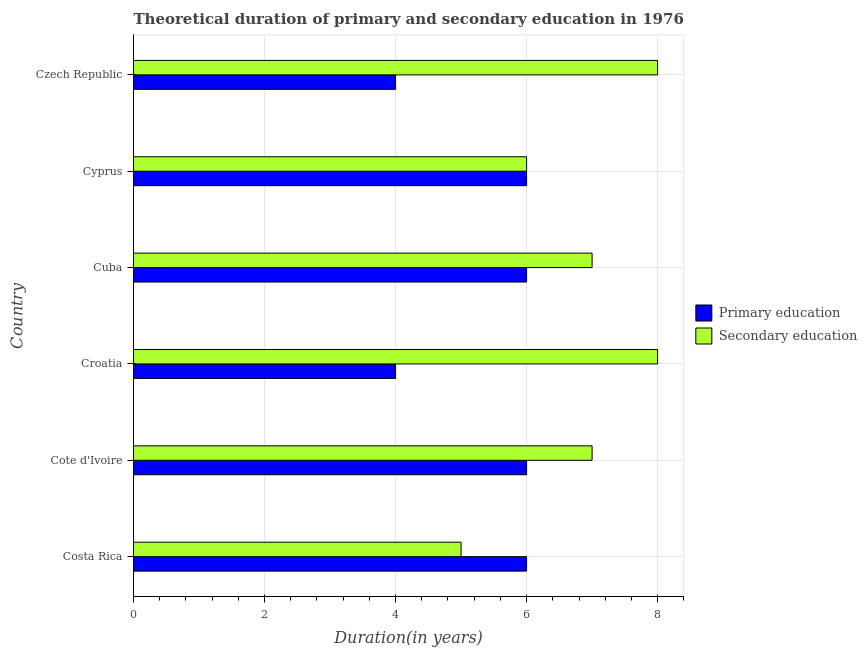How many groups of bars are there?
Your answer should be very brief. 6. Are the number of bars per tick equal to the number of legend labels?
Provide a succinct answer. Yes. Are the number of bars on each tick of the Y-axis equal?
Give a very brief answer. Yes. What is the label of the 2nd group of bars from the top?
Offer a very short reply. Cyprus. In how many cases, is the number of bars for a given country not equal to the number of legend labels?
Ensure brevity in your answer.  0. What is the duration of primary education in Cote d'Ivoire?
Provide a succinct answer. 6. Across all countries, what is the maximum duration of secondary education?
Your response must be concise. 8. Across all countries, what is the minimum duration of primary education?
Make the answer very short. 4. In which country was the duration of secondary education maximum?
Offer a terse response. Croatia. What is the total duration of secondary education in the graph?
Provide a succinct answer. 41. What is the difference between the duration of primary education in Cuba and that in Czech Republic?
Make the answer very short. 2. What is the difference between the duration of secondary education in Croatia and the duration of primary education in Cote d'Ivoire?
Make the answer very short. 2. What is the average duration of primary education per country?
Ensure brevity in your answer.  5.33. What is the difference between the duration of primary education and duration of secondary education in Costa Rica?
Your answer should be compact. 1. In how many countries, is the duration of secondary education greater than 1.2000000000000002 years?
Give a very brief answer. 6. What is the ratio of the duration of secondary education in Cote d'Ivoire to that in Cyprus?
Your answer should be very brief. 1.17. What is the difference between the highest and the second highest duration of primary education?
Your answer should be compact. 0. What is the difference between the highest and the lowest duration of secondary education?
Keep it short and to the point. 3. Is the sum of the duration of secondary education in Costa Rica and Cyprus greater than the maximum duration of primary education across all countries?
Make the answer very short. Yes. What does the 1st bar from the top in Costa Rica represents?
Make the answer very short. Secondary education. How many bars are there?
Provide a succinct answer. 12. Are all the bars in the graph horizontal?
Offer a very short reply. Yes. Does the graph contain grids?
Give a very brief answer. Yes. Where does the legend appear in the graph?
Your answer should be very brief. Center right. How many legend labels are there?
Your answer should be very brief. 2. What is the title of the graph?
Keep it short and to the point. Theoretical duration of primary and secondary education in 1976. Does "Measles" appear as one of the legend labels in the graph?
Your response must be concise. No. What is the label or title of the X-axis?
Keep it short and to the point. Duration(in years). What is the label or title of the Y-axis?
Give a very brief answer. Country. What is the Duration(in years) of Secondary education in Costa Rica?
Offer a very short reply. 5. What is the Duration(in years) in Primary education in Croatia?
Provide a short and direct response. 4. What is the Duration(in years) of Secondary education in Cuba?
Make the answer very short. 7. What is the Duration(in years) in Primary education in Czech Republic?
Provide a succinct answer. 4. What is the Duration(in years) in Secondary education in Czech Republic?
Give a very brief answer. 8. Across all countries, what is the maximum Duration(in years) in Primary education?
Offer a terse response. 6. Across all countries, what is the maximum Duration(in years) of Secondary education?
Offer a terse response. 8. What is the total Duration(in years) of Secondary education in the graph?
Ensure brevity in your answer.  41. What is the difference between the Duration(in years) in Primary education in Costa Rica and that in Cote d'Ivoire?
Keep it short and to the point. 0. What is the difference between the Duration(in years) of Secondary education in Costa Rica and that in Cote d'Ivoire?
Give a very brief answer. -2. What is the difference between the Duration(in years) in Primary education in Costa Rica and that in Croatia?
Ensure brevity in your answer.  2. What is the difference between the Duration(in years) of Primary education in Costa Rica and that in Czech Republic?
Make the answer very short. 2. What is the difference between the Duration(in years) of Secondary education in Costa Rica and that in Czech Republic?
Offer a terse response. -3. What is the difference between the Duration(in years) in Secondary education in Cote d'Ivoire and that in Croatia?
Give a very brief answer. -1. What is the difference between the Duration(in years) in Primary education in Cote d'Ivoire and that in Cuba?
Ensure brevity in your answer.  0. What is the difference between the Duration(in years) in Secondary education in Cote d'Ivoire and that in Cuba?
Offer a very short reply. 0. What is the difference between the Duration(in years) in Secondary education in Cote d'Ivoire and that in Czech Republic?
Your response must be concise. -1. What is the difference between the Duration(in years) of Primary education in Croatia and that in Cuba?
Your answer should be compact. -2. What is the difference between the Duration(in years) in Secondary education in Croatia and that in Cyprus?
Your answer should be very brief. 2. What is the difference between the Duration(in years) of Primary education in Cuba and that in Czech Republic?
Provide a short and direct response. 2. What is the difference between the Duration(in years) of Secondary education in Cuba and that in Czech Republic?
Your response must be concise. -1. What is the difference between the Duration(in years) of Secondary education in Cyprus and that in Czech Republic?
Ensure brevity in your answer.  -2. What is the difference between the Duration(in years) of Primary education in Costa Rica and the Duration(in years) of Secondary education in Cote d'Ivoire?
Your answer should be compact. -1. What is the difference between the Duration(in years) of Primary education in Costa Rica and the Duration(in years) of Secondary education in Cuba?
Give a very brief answer. -1. What is the difference between the Duration(in years) in Primary education in Costa Rica and the Duration(in years) in Secondary education in Czech Republic?
Your response must be concise. -2. What is the difference between the Duration(in years) in Primary education in Cote d'Ivoire and the Duration(in years) in Secondary education in Croatia?
Provide a succinct answer. -2. What is the difference between the Duration(in years) in Primary education in Cote d'Ivoire and the Duration(in years) in Secondary education in Cuba?
Offer a very short reply. -1. What is the difference between the Duration(in years) in Primary education in Cote d'Ivoire and the Duration(in years) in Secondary education in Czech Republic?
Give a very brief answer. -2. What is the difference between the Duration(in years) in Primary education in Croatia and the Duration(in years) in Secondary education in Cuba?
Provide a short and direct response. -3. What is the difference between the Duration(in years) of Primary education in Croatia and the Duration(in years) of Secondary education in Czech Republic?
Your response must be concise. -4. What is the average Duration(in years) in Primary education per country?
Your response must be concise. 5.33. What is the average Duration(in years) in Secondary education per country?
Your answer should be very brief. 6.83. What is the difference between the Duration(in years) in Primary education and Duration(in years) in Secondary education in Costa Rica?
Your answer should be compact. 1. What is the ratio of the Duration(in years) in Secondary education in Costa Rica to that in Cote d'Ivoire?
Offer a very short reply. 0.71. What is the ratio of the Duration(in years) of Primary education in Costa Rica to that in Cuba?
Offer a very short reply. 1. What is the ratio of the Duration(in years) in Primary education in Costa Rica to that in Cyprus?
Offer a terse response. 1. What is the ratio of the Duration(in years) in Secondary education in Costa Rica to that in Cyprus?
Keep it short and to the point. 0.83. What is the ratio of the Duration(in years) in Secondary education in Costa Rica to that in Czech Republic?
Keep it short and to the point. 0.62. What is the ratio of the Duration(in years) in Primary education in Cote d'Ivoire to that in Croatia?
Your answer should be very brief. 1.5. What is the ratio of the Duration(in years) of Primary education in Cote d'Ivoire to that in Cuba?
Make the answer very short. 1. What is the ratio of the Duration(in years) in Secondary education in Cote d'Ivoire to that in Cuba?
Provide a succinct answer. 1. What is the ratio of the Duration(in years) in Secondary education in Cote d'Ivoire to that in Cyprus?
Your answer should be compact. 1.17. What is the ratio of the Duration(in years) in Secondary education in Croatia to that in Cyprus?
Make the answer very short. 1.33. What is the ratio of the Duration(in years) of Primary education in Croatia to that in Czech Republic?
Your response must be concise. 1. What is the ratio of the Duration(in years) in Primary education in Cuba to that in Cyprus?
Your answer should be very brief. 1. What is the ratio of the Duration(in years) in Primary education in Cuba to that in Czech Republic?
Provide a succinct answer. 1.5. What is the ratio of the Duration(in years) of Primary education in Cyprus to that in Czech Republic?
Your response must be concise. 1.5. What is the difference between the highest and the second highest Duration(in years) in Primary education?
Provide a short and direct response. 0. What is the difference between the highest and the lowest Duration(in years) in Primary education?
Make the answer very short. 2. 